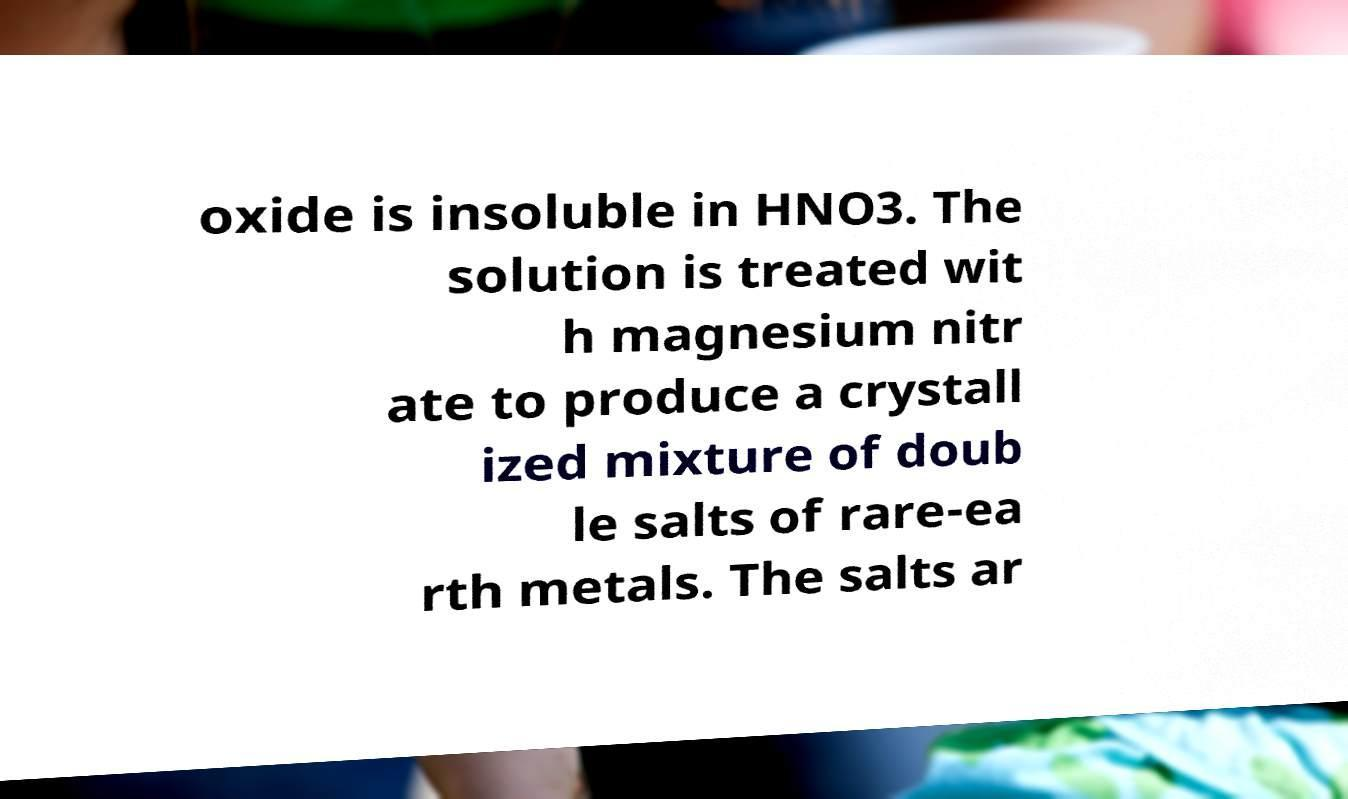Can you read and provide the text displayed in the image?This photo seems to have some interesting text. Can you extract and type it out for me? oxide is insoluble in HNO3. The solution is treated wit h magnesium nitr ate to produce a crystall ized mixture of doub le salts of rare-ea rth metals. The salts ar 